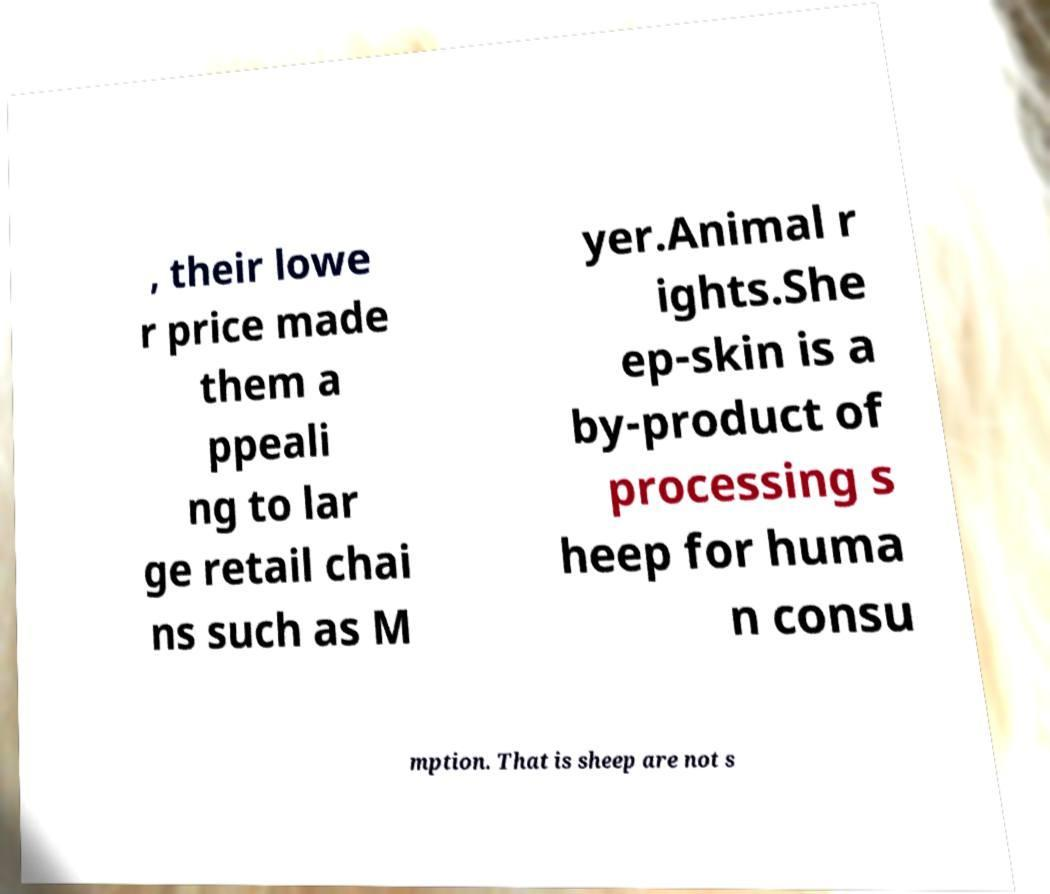For documentation purposes, I need the text within this image transcribed. Could you provide that? , their lowe r price made them a ppeali ng to lar ge retail chai ns such as M yer.Animal r ights.She ep-skin is a by-product of processing s heep for huma n consu mption. That is sheep are not s 